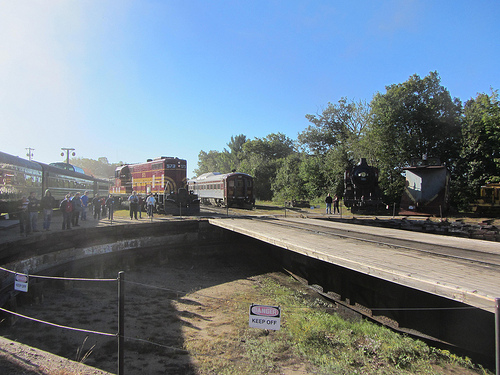Which place is it? The scene appears to be a train station. 